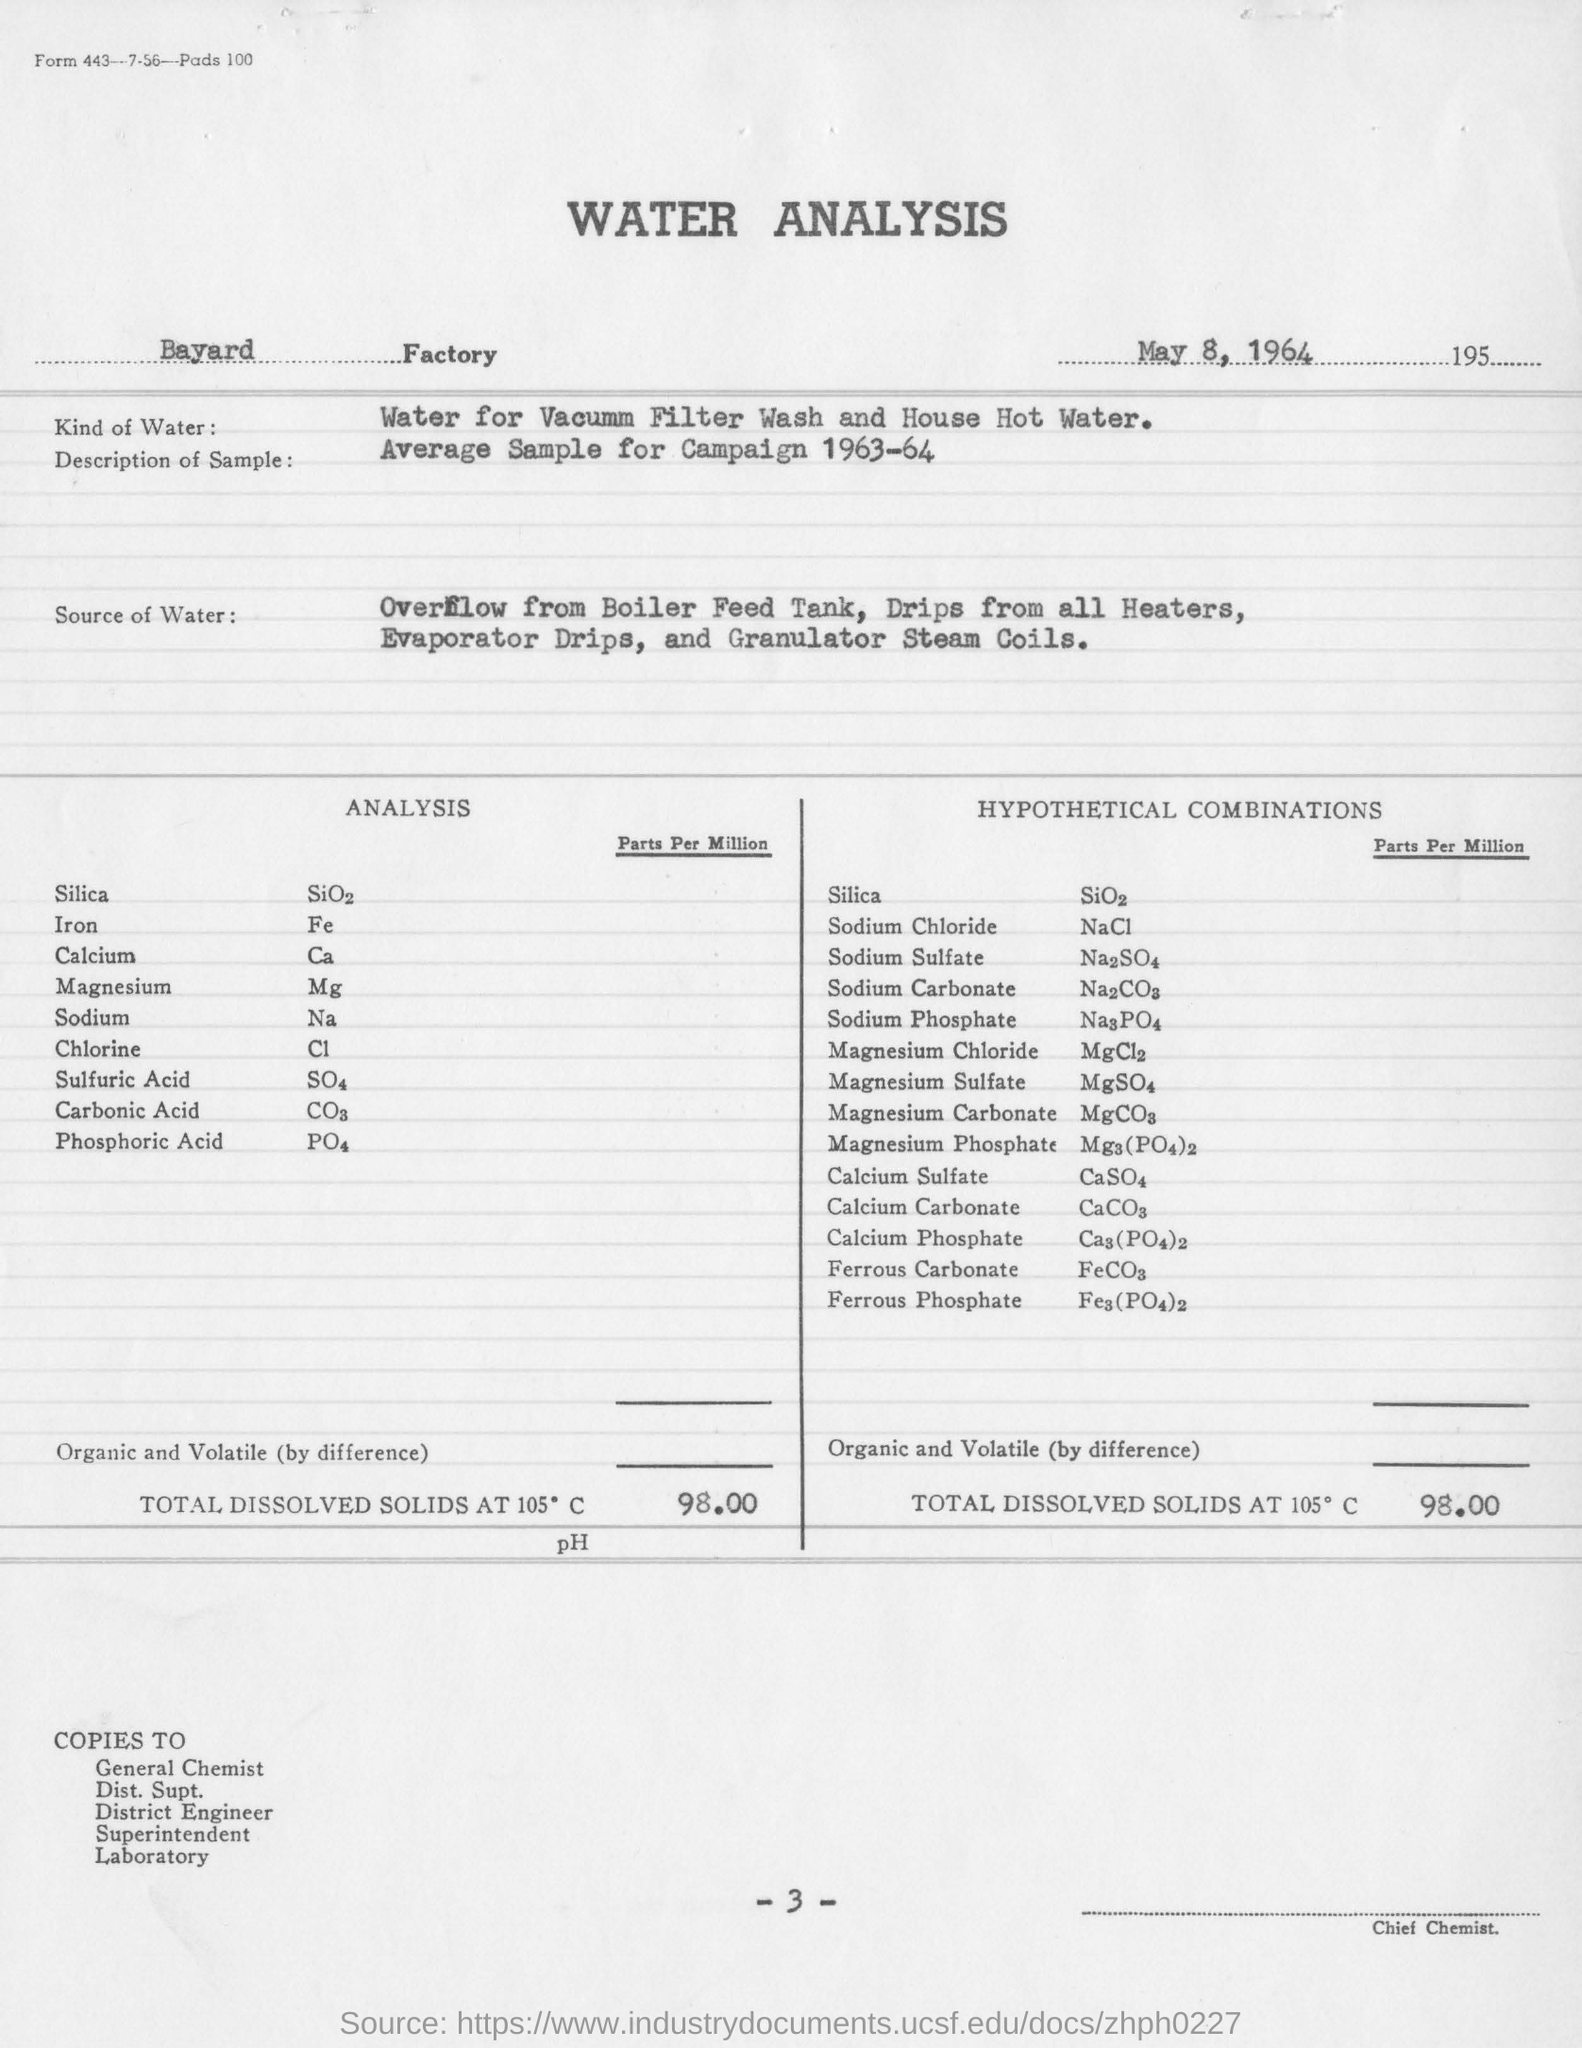Indicate a few pertinent items in this graphic. The name of the factory mentioned in this report is Bayard. The date mentioned in this report is May 8, 1964. 